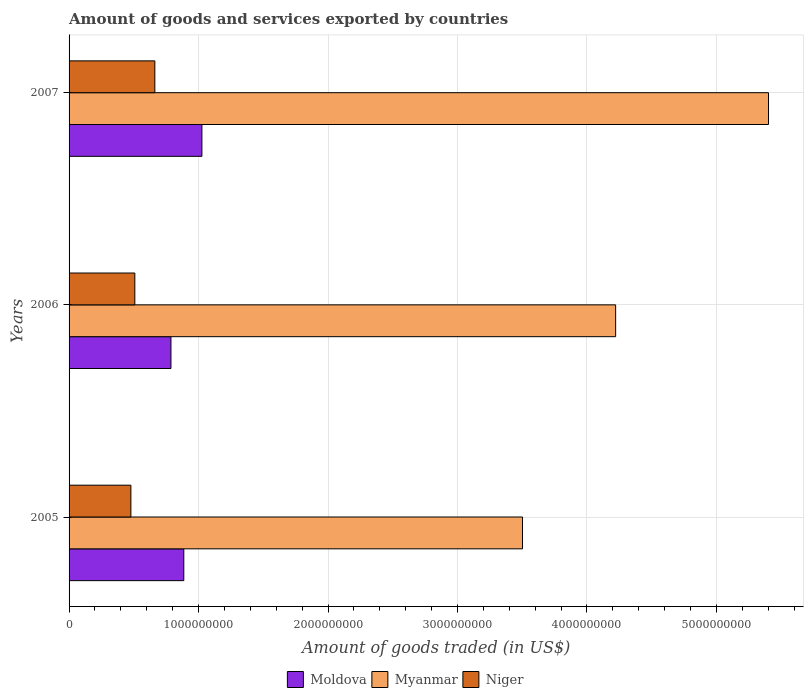Are the number of bars per tick equal to the number of legend labels?
Give a very brief answer. Yes. How many bars are there on the 2nd tick from the top?
Give a very brief answer. 3. How many bars are there on the 2nd tick from the bottom?
Your answer should be compact. 3. What is the label of the 3rd group of bars from the top?
Offer a very short reply. 2005. In how many cases, is the number of bars for a given year not equal to the number of legend labels?
Provide a succinct answer. 0. What is the total amount of goods and services exported in Moldova in 2005?
Provide a short and direct response. 8.86e+08. Across all years, what is the maximum total amount of goods and services exported in Myanmar?
Keep it short and to the point. 5.40e+09. Across all years, what is the minimum total amount of goods and services exported in Niger?
Your answer should be compact. 4.78e+08. In which year was the total amount of goods and services exported in Moldova minimum?
Provide a succinct answer. 2006. What is the total total amount of goods and services exported in Moldova in the graph?
Your answer should be compact. 2.70e+09. What is the difference between the total amount of goods and services exported in Niger in 2006 and that in 2007?
Offer a terse response. -1.55e+08. What is the difference between the total amount of goods and services exported in Moldova in 2006 and the total amount of goods and services exported in Myanmar in 2005?
Give a very brief answer. -2.72e+09. What is the average total amount of goods and services exported in Myanmar per year?
Offer a terse response. 4.38e+09. In the year 2006, what is the difference between the total amount of goods and services exported in Moldova and total amount of goods and services exported in Niger?
Your answer should be very brief. 2.79e+08. What is the ratio of the total amount of goods and services exported in Niger in 2005 to that in 2006?
Ensure brevity in your answer.  0.94. Is the total amount of goods and services exported in Myanmar in 2005 less than that in 2007?
Offer a very short reply. Yes. Is the difference between the total amount of goods and services exported in Moldova in 2006 and 2007 greater than the difference between the total amount of goods and services exported in Niger in 2006 and 2007?
Give a very brief answer. No. What is the difference between the highest and the second highest total amount of goods and services exported in Myanmar?
Provide a succinct answer. 1.18e+09. What is the difference between the highest and the lowest total amount of goods and services exported in Moldova?
Your answer should be compact. 2.39e+08. What does the 2nd bar from the top in 2007 represents?
Your answer should be very brief. Myanmar. What does the 3rd bar from the bottom in 2005 represents?
Offer a very short reply. Niger. Is it the case that in every year, the sum of the total amount of goods and services exported in Moldova and total amount of goods and services exported in Myanmar is greater than the total amount of goods and services exported in Niger?
Offer a terse response. Yes. How many bars are there?
Your answer should be very brief. 9. Are all the bars in the graph horizontal?
Ensure brevity in your answer.  Yes. Where does the legend appear in the graph?
Make the answer very short. Bottom center. What is the title of the graph?
Provide a short and direct response. Amount of goods and services exported by countries. Does "Central African Republic" appear as one of the legend labels in the graph?
Make the answer very short. No. What is the label or title of the X-axis?
Provide a short and direct response. Amount of goods traded (in US$). What is the Amount of goods traded (in US$) in Moldova in 2005?
Make the answer very short. 8.86e+08. What is the Amount of goods traded (in US$) of Myanmar in 2005?
Your response must be concise. 3.50e+09. What is the Amount of goods traded (in US$) in Niger in 2005?
Offer a terse response. 4.78e+08. What is the Amount of goods traded (in US$) of Moldova in 2006?
Your response must be concise. 7.87e+08. What is the Amount of goods traded (in US$) in Myanmar in 2006?
Provide a short and direct response. 4.22e+09. What is the Amount of goods traded (in US$) in Niger in 2006?
Provide a short and direct response. 5.08e+08. What is the Amount of goods traded (in US$) in Moldova in 2007?
Your response must be concise. 1.03e+09. What is the Amount of goods traded (in US$) of Myanmar in 2007?
Provide a succinct answer. 5.40e+09. What is the Amount of goods traded (in US$) of Niger in 2007?
Your answer should be very brief. 6.63e+08. Across all years, what is the maximum Amount of goods traded (in US$) in Moldova?
Keep it short and to the point. 1.03e+09. Across all years, what is the maximum Amount of goods traded (in US$) in Myanmar?
Offer a terse response. 5.40e+09. Across all years, what is the maximum Amount of goods traded (in US$) of Niger?
Keep it short and to the point. 6.63e+08. Across all years, what is the minimum Amount of goods traded (in US$) in Moldova?
Your answer should be compact. 7.87e+08. Across all years, what is the minimum Amount of goods traded (in US$) of Myanmar?
Ensure brevity in your answer.  3.50e+09. Across all years, what is the minimum Amount of goods traded (in US$) of Niger?
Your answer should be compact. 4.78e+08. What is the total Amount of goods traded (in US$) of Moldova in the graph?
Offer a terse response. 2.70e+09. What is the total Amount of goods traded (in US$) of Myanmar in the graph?
Provide a succinct answer. 1.31e+1. What is the total Amount of goods traded (in US$) of Niger in the graph?
Keep it short and to the point. 1.65e+09. What is the difference between the Amount of goods traded (in US$) of Moldova in 2005 and that in 2006?
Provide a succinct answer. 9.92e+07. What is the difference between the Amount of goods traded (in US$) in Myanmar in 2005 and that in 2006?
Provide a succinct answer. -7.19e+08. What is the difference between the Amount of goods traded (in US$) of Niger in 2005 and that in 2006?
Your response must be concise. -3.04e+07. What is the difference between the Amount of goods traded (in US$) of Moldova in 2005 and that in 2007?
Offer a very short reply. -1.40e+08. What is the difference between the Amount of goods traded (in US$) in Myanmar in 2005 and that in 2007?
Offer a very short reply. -1.90e+09. What is the difference between the Amount of goods traded (in US$) of Niger in 2005 and that in 2007?
Provide a succinct answer. -1.85e+08. What is the difference between the Amount of goods traded (in US$) of Moldova in 2006 and that in 2007?
Provide a succinct answer. -2.39e+08. What is the difference between the Amount of goods traded (in US$) of Myanmar in 2006 and that in 2007?
Your answer should be compact. -1.18e+09. What is the difference between the Amount of goods traded (in US$) in Niger in 2006 and that in 2007?
Give a very brief answer. -1.55e+08. What is the difference between the Amount of goods traded (in US$) of Moldova in 2005 and the Amount of goods traded (in US$) of Myanmar in 2006?
Your answer should be very brief. -3.34e+09. What is the difference between the Amount of goods traded (in US$) in Moldova in 2005 and the Amount of goods traded (in US$) in Niger in 2006?
Provide a short and direct response. 3.78e+08. What is the difference between the Amount of goods traded (in US$) of Myanmar in 2005 and the Amount of goods traded (in US$) of Niger in 2006?
Your answer should be compact. 2.99e+09. What is the difference between the Amount of goods traded (in US$) of Moldova in 2005 and the Amount of goods traded (in US$) of Myanmar in 2007?
Make the answer very short. -4.52e+09. What is the difference between the Amount of goods traded (in US$) of Moldova in 2005 and the Amount of goods traded (in US$) of Niger in 2007?
Ensure brevity in your answer.  2.24e+08. What is the difference between the Amount of goods traded (in US$) in Myanmar in 2005 and the Amount of goods traded (in US$) in Niger in 2007?
Your answer should be very brief. 2.84e+09. What is the difference between the Amount of goods traded (in US$) of Moldova in 2006 and the Amount of goods traded (in US$) of Myanmar in 2007?
Offer a terse response. -4.62e+09. What is the difference between the Amount of goods traded (in US$) of Moldova in 2006 and the Amount of goods traded (in US$) of Niger in 2007?
Make the answer very short. 1.24e+08. What is the difference between the Amount of goods traded (in US$) in Myanmar in 2006 and the Amount of goods traded (in US$) in Niger in 2007?
Keep it short and to the point. 3.56e+09. What is the average Amount of goods traded (in US$) of Moldova per year?
Your response must be concise. 9.00e+08. What is the average Amount of goods traded (in US$) of Myanmar per year?
Offer a very short reply. 4.38e+09. What is the average Amount of goods traded (in US$) in Niger per year?
Provide a short and direct response. 5.49e+08. In the year 2005, what is the difference between the Amount of goods traded (in US$) of Moldova and Amount of goods traded (in US$) of Myanmar?
Make the answer very short. -2.62e+09. In the year 2005, what is the difference between the Amount of goods traded (in US$) in Moldova and Amount of goods traded (in US$) in Niger?
Provide a short and direct response. 4.09e+08. In the year 2005, what is the difference between the Amount of goods traded (in US$) of Myanmar and Amount of goods traded (in US$) of Niger?
Offer a very short reply. 3.02e+09. In the year 2006, what is the difference between the Amount of goods traded (in US$) in Moldova and Amount of goods traded (in US$) in Myanmar?
Offer a terse response. -3.43e+09. In the year 2006, what is the difference between the Amount of goods traded (in US$) in Moldova and Amount of goods traded (in US$) in Niger?
Give a very brief answer. 2.79e+08. In the year 2006, what is the difference between the Amount of goods traded (in US$) of Myanmar and Amount of goods traded (in US$) of Niger?
Offer a terse response. 3.71e+09. In the year 2007, what is the difference between the Amount of goods traded (in US$) in Moldova and Amount of goods traded (in US$) in Myanmar?
Provide a succinct answer. -4.38e+09. In the year 2007, what is the difference between the Amount of goods traded (in US$) of Moldova and Amount of goods traded (in US$) of Niger?
Your answer should be very brief. 3.63e+08. In the year 2007, what is the difference between the Amount of goods traded (in US$) of Myanmar and Amount of goods traded (in US$) of Niger?
Keep it short and to the point. 4.74e+09. What is the ratio of the Amount of goods traded (in US$) in Moldova in 2005 to that in 2006?
Offer a very short reply. 1.13. What is the ratio of the Amount of goods traded (in US$) in Myanmar in 2005 to that in 2006?
Give a very brief answer. 0.83. What is the ratio of the Amount of goods traded (in US$) in Niger in 2005 to that in 2006?
Your response must be concise. 0.94. What is the ratio of the Amount of goods traded (in US$) of Moldova in 2005 to that in 2007?
Offer a terse response. 0.86. What is the ratio of the Amount of goods traded (in US$) in Myanmar in 2005 to that in 2007?
Provide a succinct answer. 0.65. What is the ratio of the Amount of goods traded (in US$) in Niger in 2005 to that in 2007?
Your answer should be compact. 0.72. What is the ratio of the Amount of goods traded (in US$) of Moldova in 2006 to that in 2007?
Your answer should be compact. 0.77. What is the ratio of the Amount of goods traded (in US$) of Myanmar in 2006 to that in 2007?
Offer a very short reply. 0.78. What is the ratio of the Amount of goods traded (in US$) in Niger in 2006 to that in 2007?
Make the answer very short. 0.77. What is the difference between the highest and the second highest Amount of goods traded (in US$) of Moldova?
Provide a succinct answer. 1.40e+08. What is the difference between the highest and the second highest Amount of goods traded (in US$) in Myanmar?
Ensure brevity in your answer.  1.18e+09. What is the difference between the highest and the second highest Amount of goods traded (in US$) in Niger?
Provide a short and direct response. 1.55e+08. What is the difference between the highest and the lowest Amount of goods traded (in US$) of Moldova?
Your answer should be compact. 2.39e+08. What is the difference between the highest and the lowest Amount of goods traded (in US$) of Myanmar?
Provide a short and direct response. 1.90e+09. What is the difference between the highest and the lowest Amount of goods traded (in US$) in Niger?
Ensure brevity in your answer.  1.85e+08. 